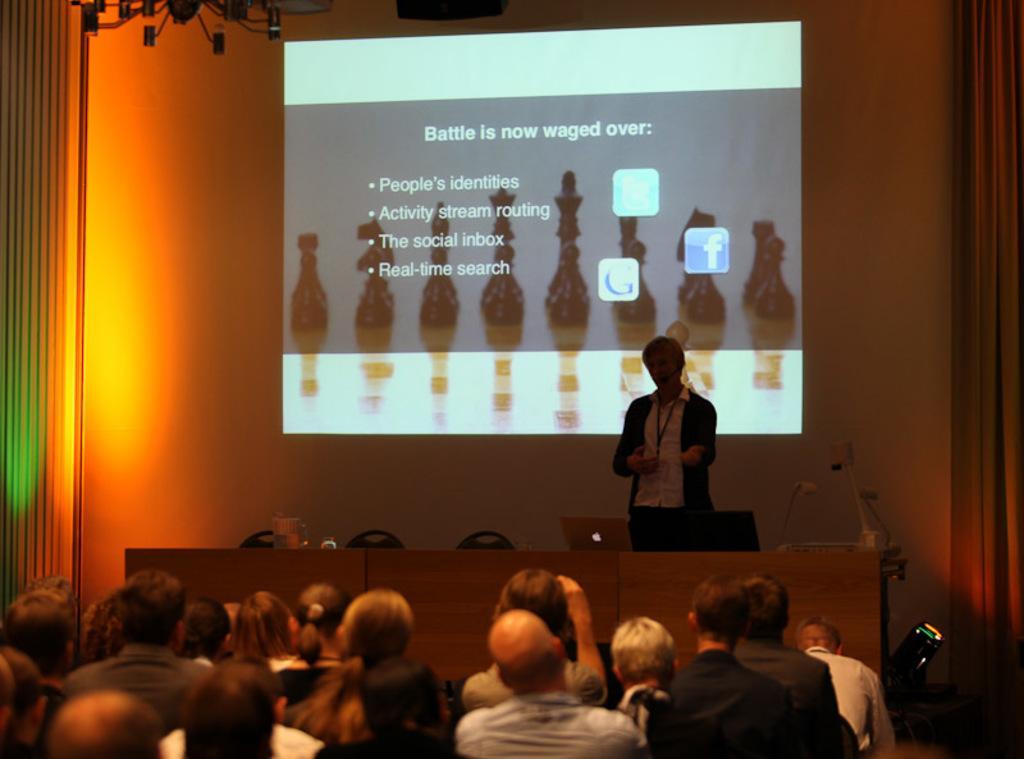Could you give a brief overview of what you see in this image? In this image we can see a man standing on the dais and a table is placed in front of him. On the table there are laptops, disposal bottle and a electric light. In the background there is a display screen. In the foreground we can see people sitting on the chairs. 